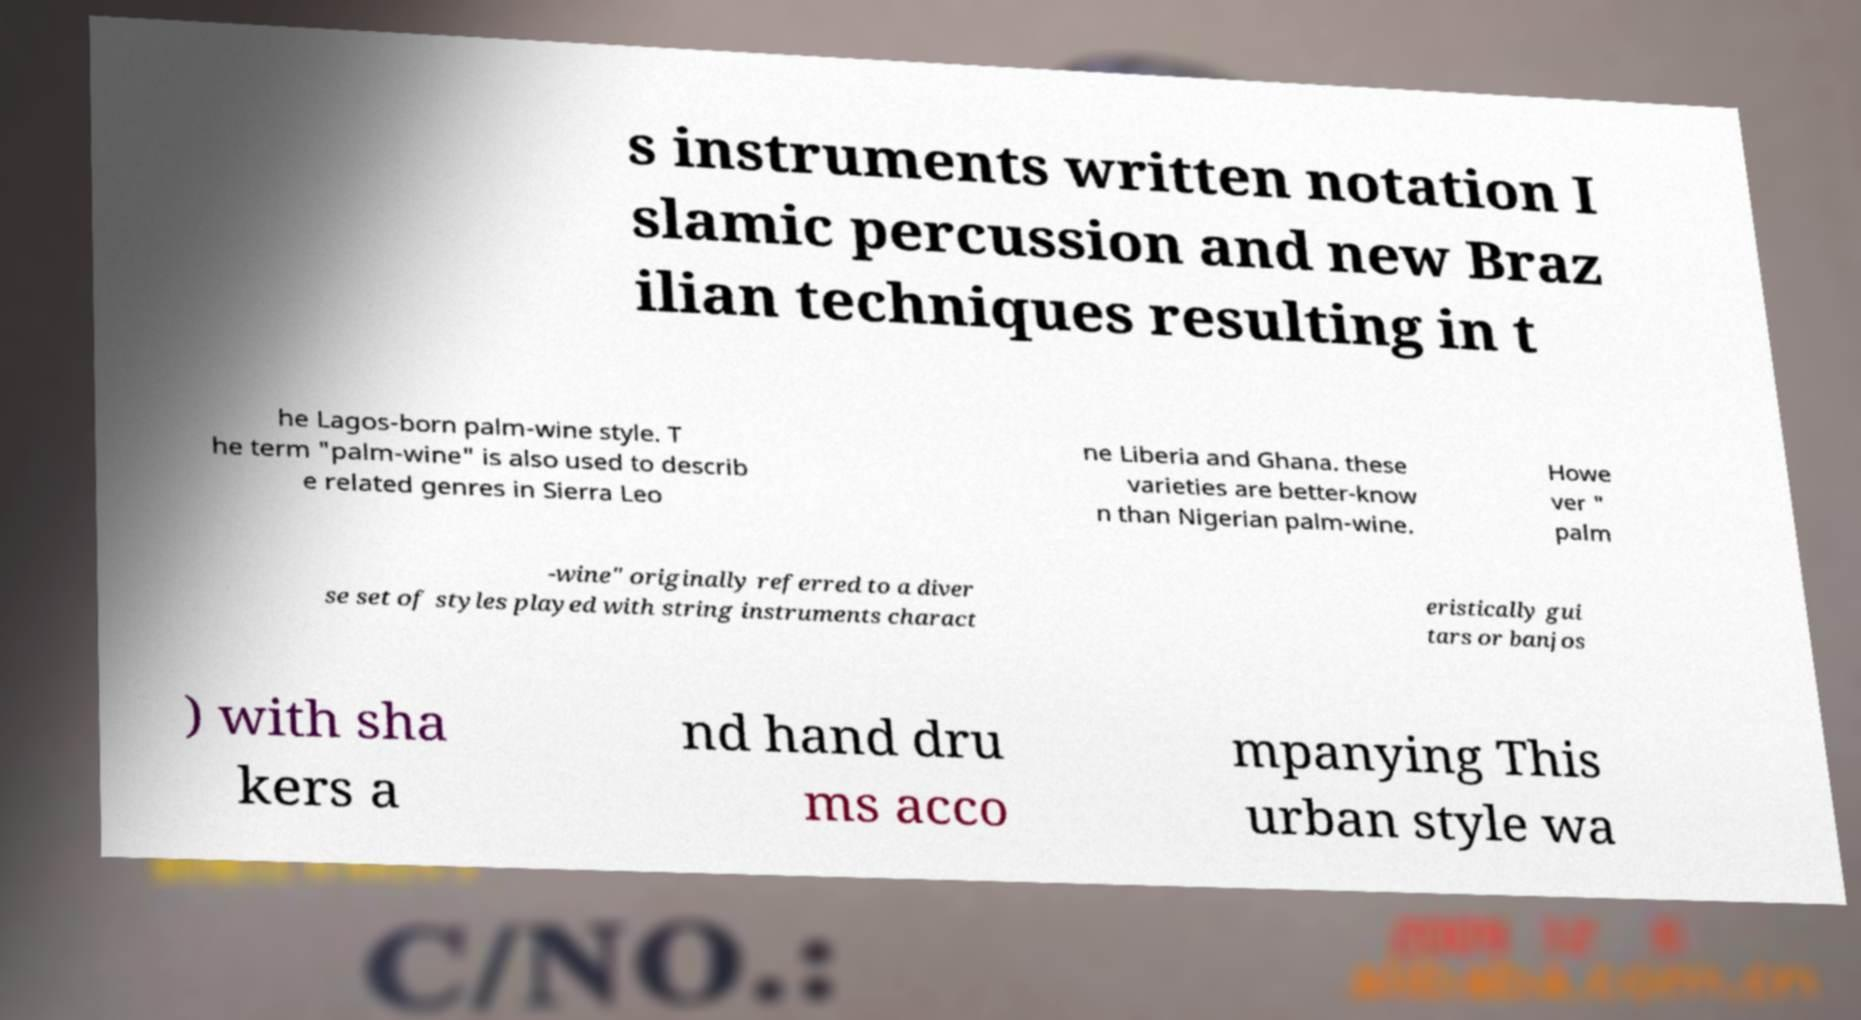I need the written content from this picture converted into text. Can you do that? s instruments written notation I slamic percussion and new Braz ilian techniques resulting in t he Lagos-born palm-wine style. T he term "palm-wine" is also used to describ e related genres in Sierra Leo ne Liberia and Ghana. these varieties are better-know n than Nigerian palm-wine. Howe ver " palm -wine" originally referred to a diver se set of styles played with string instruments charact eristically gui tars or banjos ) with sha kers a nd hand dru ms acco mpanying This urban style wa 